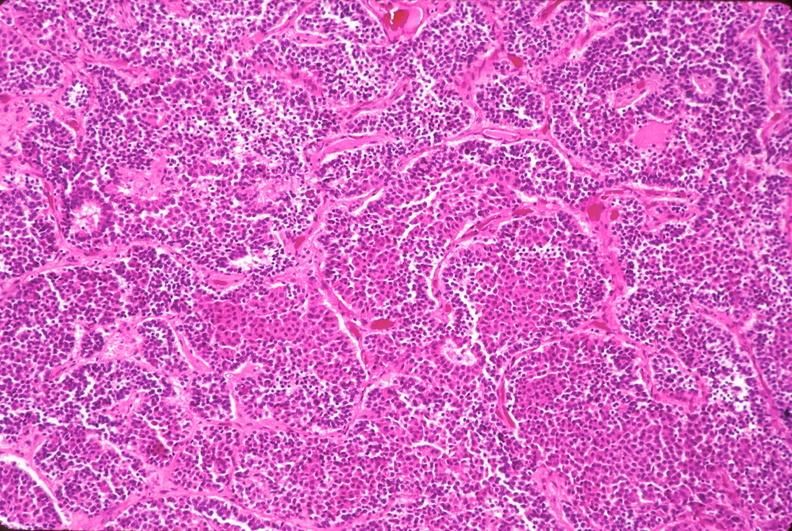what is present?
Answer the question using a single word or phrase. Endocrine 